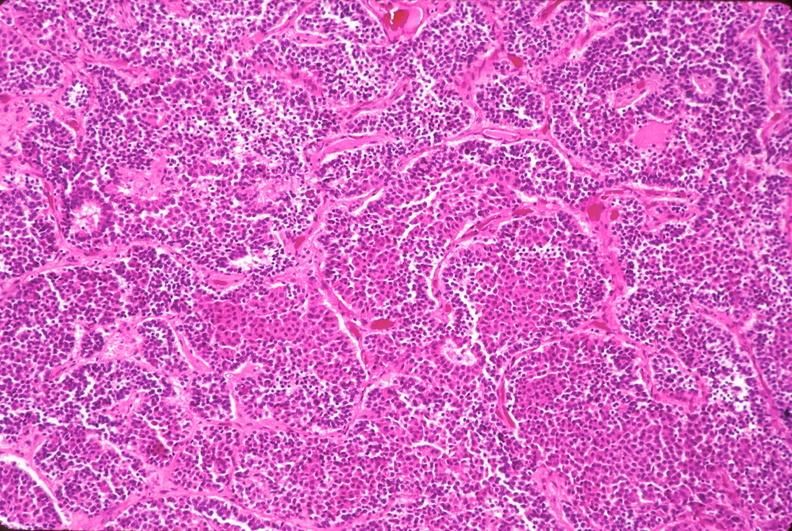what is present?
Answer the question using a single word or phrase. Endocrine 